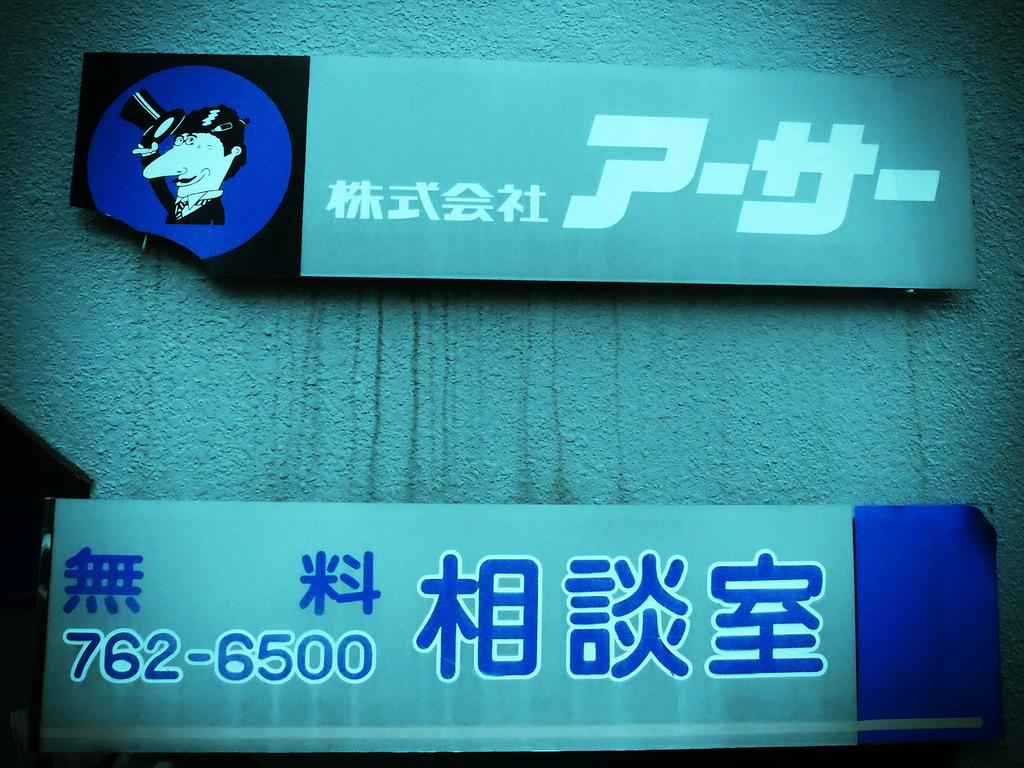How many boards can be seen in the image? There are 2 boards in the image. Where are the boards located? The boards are on a wall. Can you see a monkey climbing the tree in the image? There is no tree or monkey present in the image; only the 2 boards on a wall are visible. 